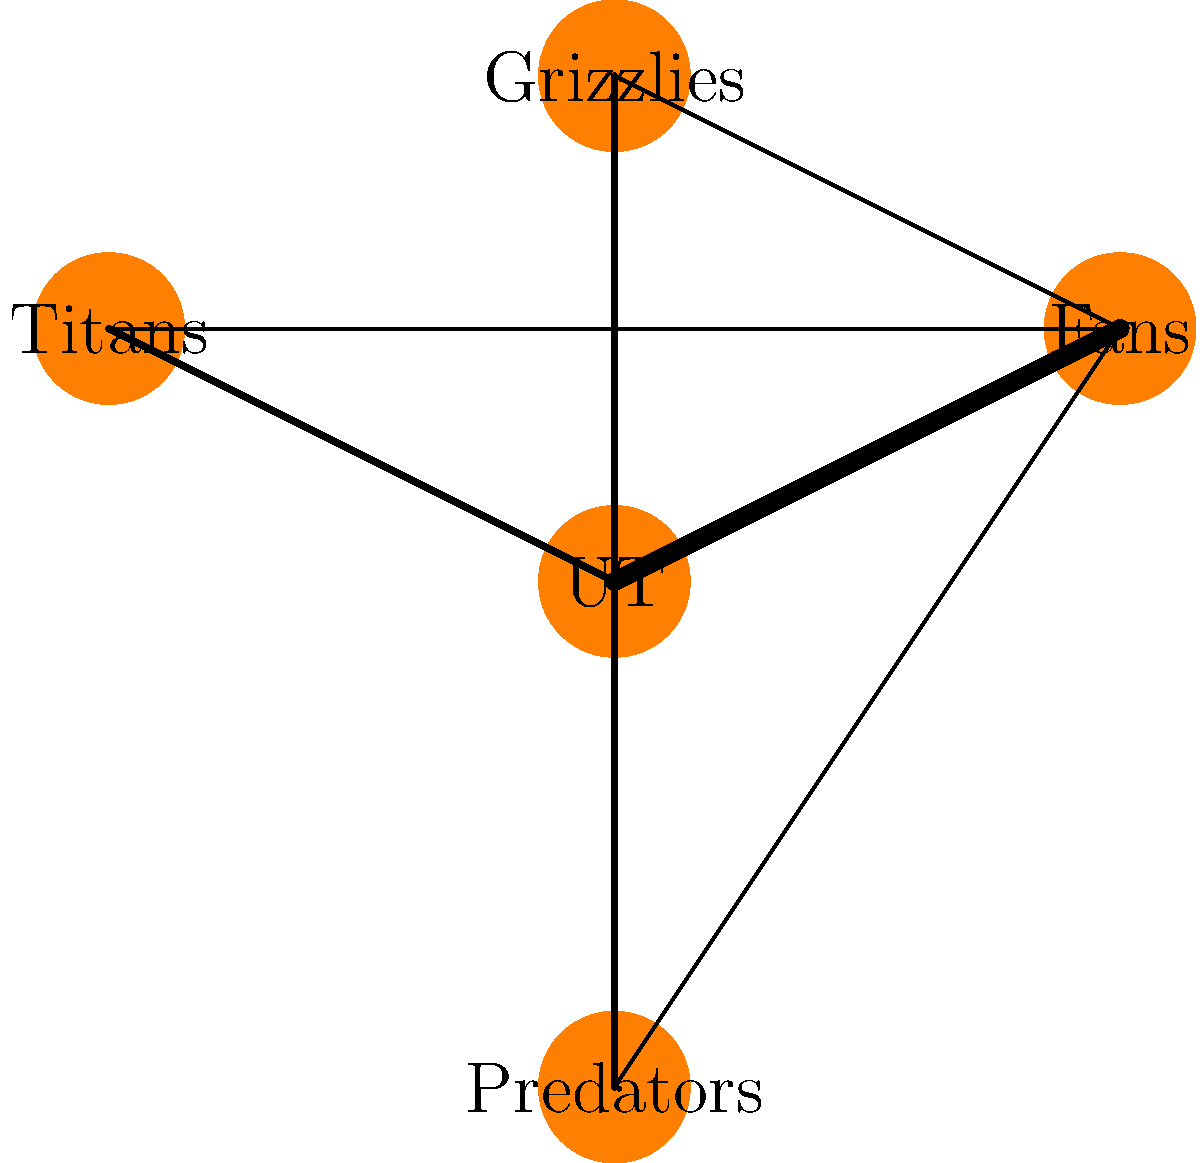As a passionate Tennessee Volunteers supporter, you're analyzing the network of Tennessee sports teams and their fan bases. In the given network diagram, nodes represent teams and fan bases, while edge thickness indicates the strength of connection. Which node has the highest degree centrality, and how might this relate to the emotional impact on fans like yourself? To answer this question, let's break it down step-by-step:

1. Understand degree centrality: Degree centrality is a measure of the number of connections a node has in a network.

2. Identify the nodes:
   - UT (University of Tennessee)
   - Fans
   - Titans
   - Grizzlies
   - Predators

3. Count the connections for each node:
   - UT: 4 connections (to Fans, Titans, Grizzlies, and Predators)
   - Fans: 4 connections (to UT, Titans, Grizzlies, and Predators)
   - Titans: 2 connections (to UT and Fans)
   - Grizzlies: 2 connections (to UT and Fans)
   - Predators: 2 connections (to UT and Fans)

4. Determine the node with the highest degree centrality:
   Both UT and Fans have 4 connections, which is the highest in the network.

5. Consider the emotional impact:
   As a Tennessee Volunteers fan, the high centrality of both UT and Fans nodes suggests that the University of Tennessee and its fan base play a crucial role in connecting various sports teams in the state. This central position can intensify the emotional connection between fans and the teams, as the success or failure of one team can ripple through the entire network.

6. Relate to songwriting:
   The central position of UT and its fans in this network could inspire songwriting themes about unity, shared experiences, and the power of fandom in bringing together diverse sports communities across Tennessee.
Answer: UT and Fans (tied); intensifies emotional connections across teams 